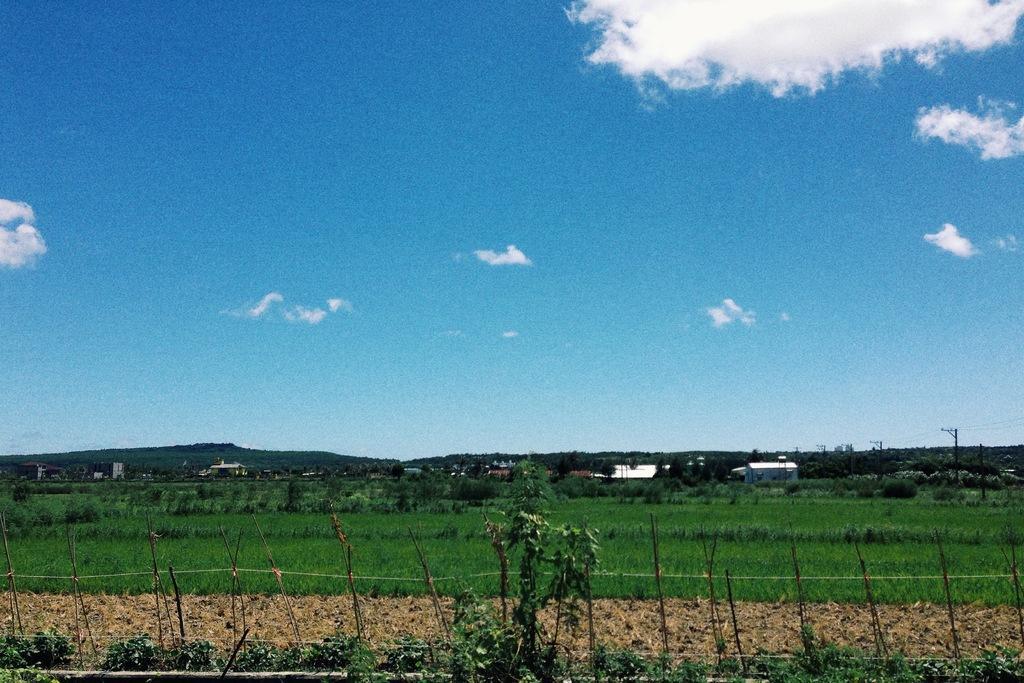Please provide a concise description of this image. This is the grass. I can see the trees. This looks like a fence. In the background, I think these are the houses. I can see the current polls. These are the clouds in the sky. 